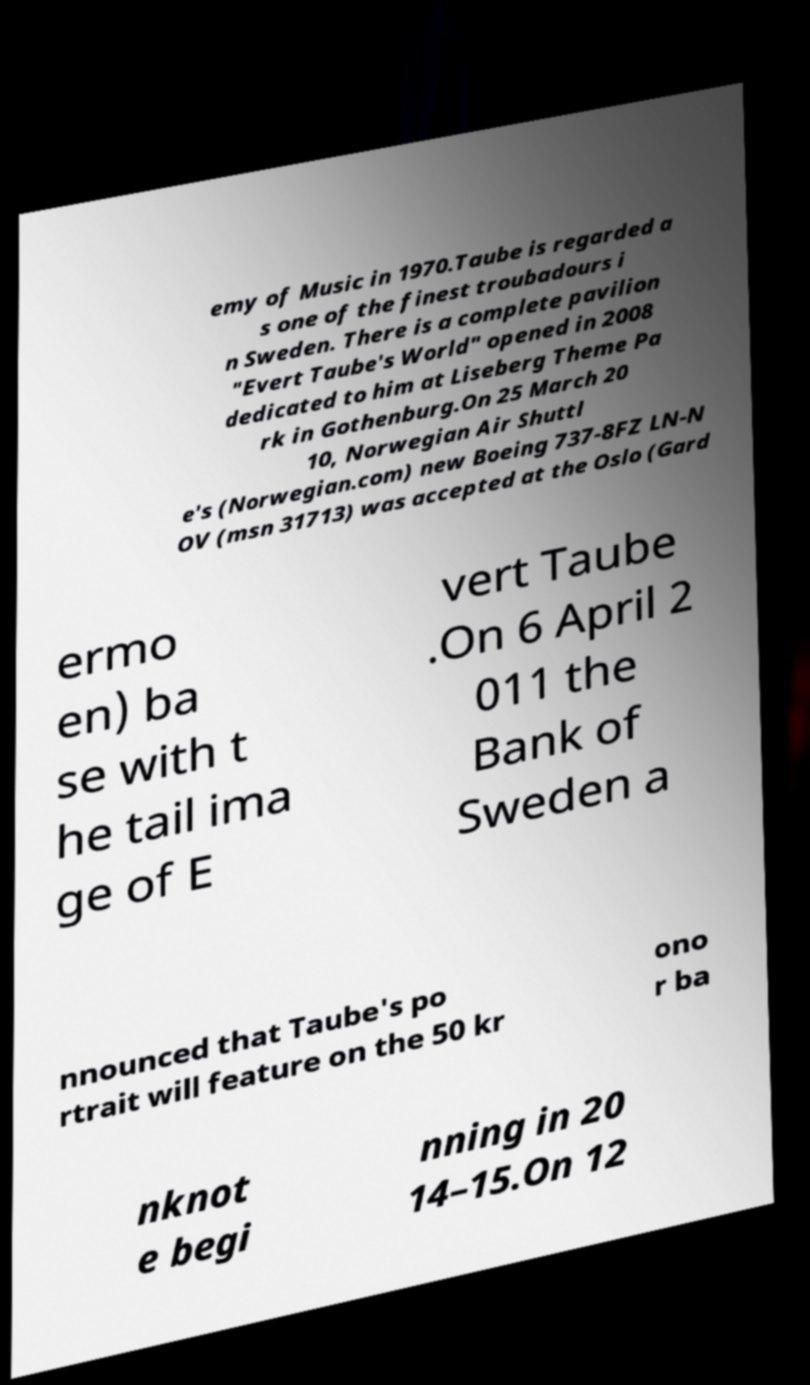What messages or text are displayed in this image? I need them in a readable, typed format. emy of Music in 1970.Taube is regarded a s one of the finest troubadours i n Sweden. There is a complete pavilion "Evert Taube's World" opened in 2008 dedicated to him at Liseberg Theme Pa rk in Gothenburg.On 25 March 20 10, Norwegian Air Shuttl e's (Norwegian.com) new Boeing 737-8FZ LN-N OV (msn 31713) was accepted at the Oslo (Gard ermo en) ba se with t he tail ima ge of E vert Taube .On 6 April 2 011 the Bank of Sweden a nnounced that Taube's po rtrait will feature on the 50 kr ono r ba nknot e begi nning in 20 14–15.On 12 